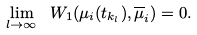Convert formula to latex. <formula><loc_0><loc_0><loc_500><loc_500>\lim _ { l \to \infty } \ W _ { 1 } ( \mu _ { i } ( t _ { k _ { l } } ) , \overline { \mu } _ { i } ) = 0 .</formula> 